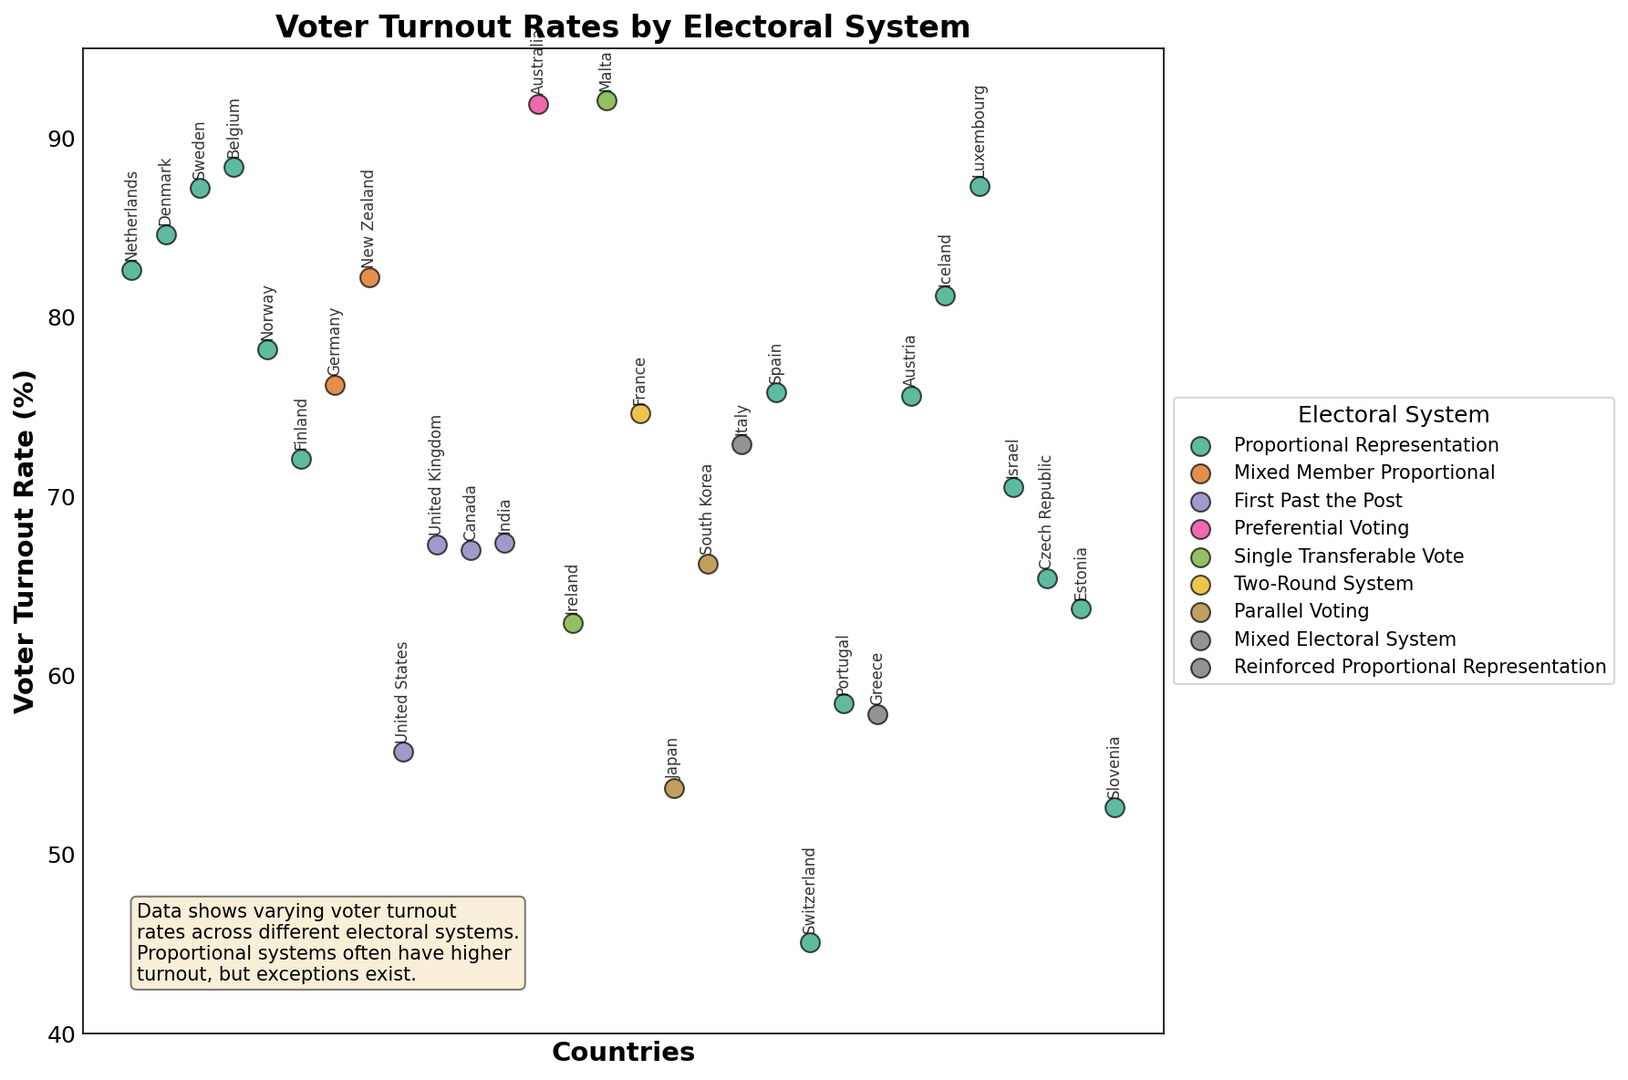what is the country with the highest voter turnout rate? To find the country with the highest voter turnout rate, examine the plot for the point positioned at the highest place on the Y-axis. The country label "Australia" appears at this position with a voter turnout rate of approximately 91.9%
Answer: Australia Which country uses the Proportional Representation system and has the lowest voter turnout? Look for the points labeled with "Proportional Representation" color marker, then find the one positioned lowest on the Y-axis. The label "Switzerland" is associated with the lowest voter turnout for this system at around 45.1%
Answer: Switzerland Compare the voter turnout rates of Mixed Member Proportional and First Past the Post systems; which one generally has higher turnout rates according to the plot? Identify the points labeled as "Mixed Member Proportional" and "First Past the Post" on the plot, and then compare their heights on the Y-axis. "Mixed Member Proportional" countries (Germany, New Zealand) generally have higher voter turnout rates compared to "First Past the Post" countries (United States, Canada, United Kingdom, India)
Answer: Mixed Member Proportional On average, do countries with Proportional Representation have higher voter turnout rates than countries with First Past the Post? Calculate the average voter turnout for both systems by summing the voter turnout rates for each country in those groups and dividing by the number of countries in the respective groups. "Proportional Representation" countries generally show higher turnout rates on the plot.
Answer: Yes Is there any electoral system with a turnout rate consistently below 60%? Examine the plot for any system's points consistently positioned below the 60% mark on the Y-axis. The "First Past the Post" system (USA at 55.7%), "Parallel Voting" (Japan at 53.7%), and "Proportional Representation" (Switzerland at 45.1%, Slovenia at 52.6%, Portugal at 58.4%, Estonia at 63.7%, and Greece at 57.8%) indicate voter turnouts around or below 60%
Answer: Yes How does Malta's voter turnout compare with other countries using the Single Transferable Vote system? Look at the points labeled "Single Transferable Vote" (Malta, Ireland) and compare their heights on the plot. Malta's voter turnout rate (92.1%) is much higher than Ireland's (62.9%)
Answer: Malta's turnout is higher Does any country with the Mixed Electoral System have a voter turnout rate above 72%? Red points representing "Mixed Electoral System" should be examined. Italy shows a voter turnout rate of around 72.9%
Answer: Yes, Italy at 72.9% Which country with a Parallel Voting system has a higher voter turnout rate? Compare the points labeled "Parallel Voting" on the plot (Japan and South Korea). South Korea is higher at 66.2% compared to Japan at 53.7%
Answer: South Korea What is the minimum voter turnout rate among all countries, and which system is it associated with? Identify the point at the lowest position on the Y-axis and note its electorate system from the color. The label "Switzerland" with Proportional Representation at 45.1% is the lowest
Answer: Switzerland, Proportional Representation 